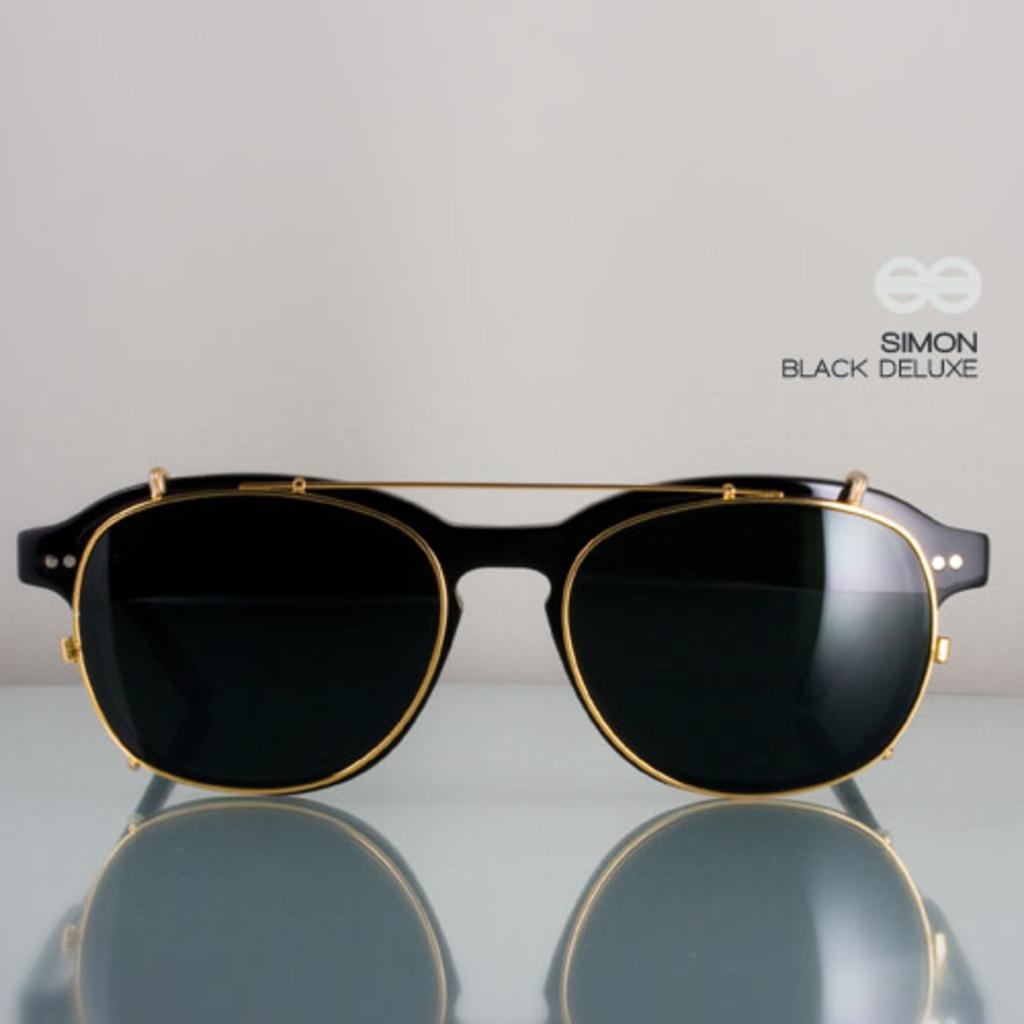What type of eyewear is present in the image? There are black sunglasses in the image. Where are the sunglasses located? The sunglasses are placed on a glass table. What is the color of the background in the image? The background in the image is white. Can you describe any imperfections in the image? There is a small water mark on the right side of the image. Who is the creator of the sunglasses in the image? The image does not provide information about the creator of the sunglasses. How does the record player in the image contribute to the overall aesthetic? There is no record player present in the image; it only features black sunglasses on a glass table. 